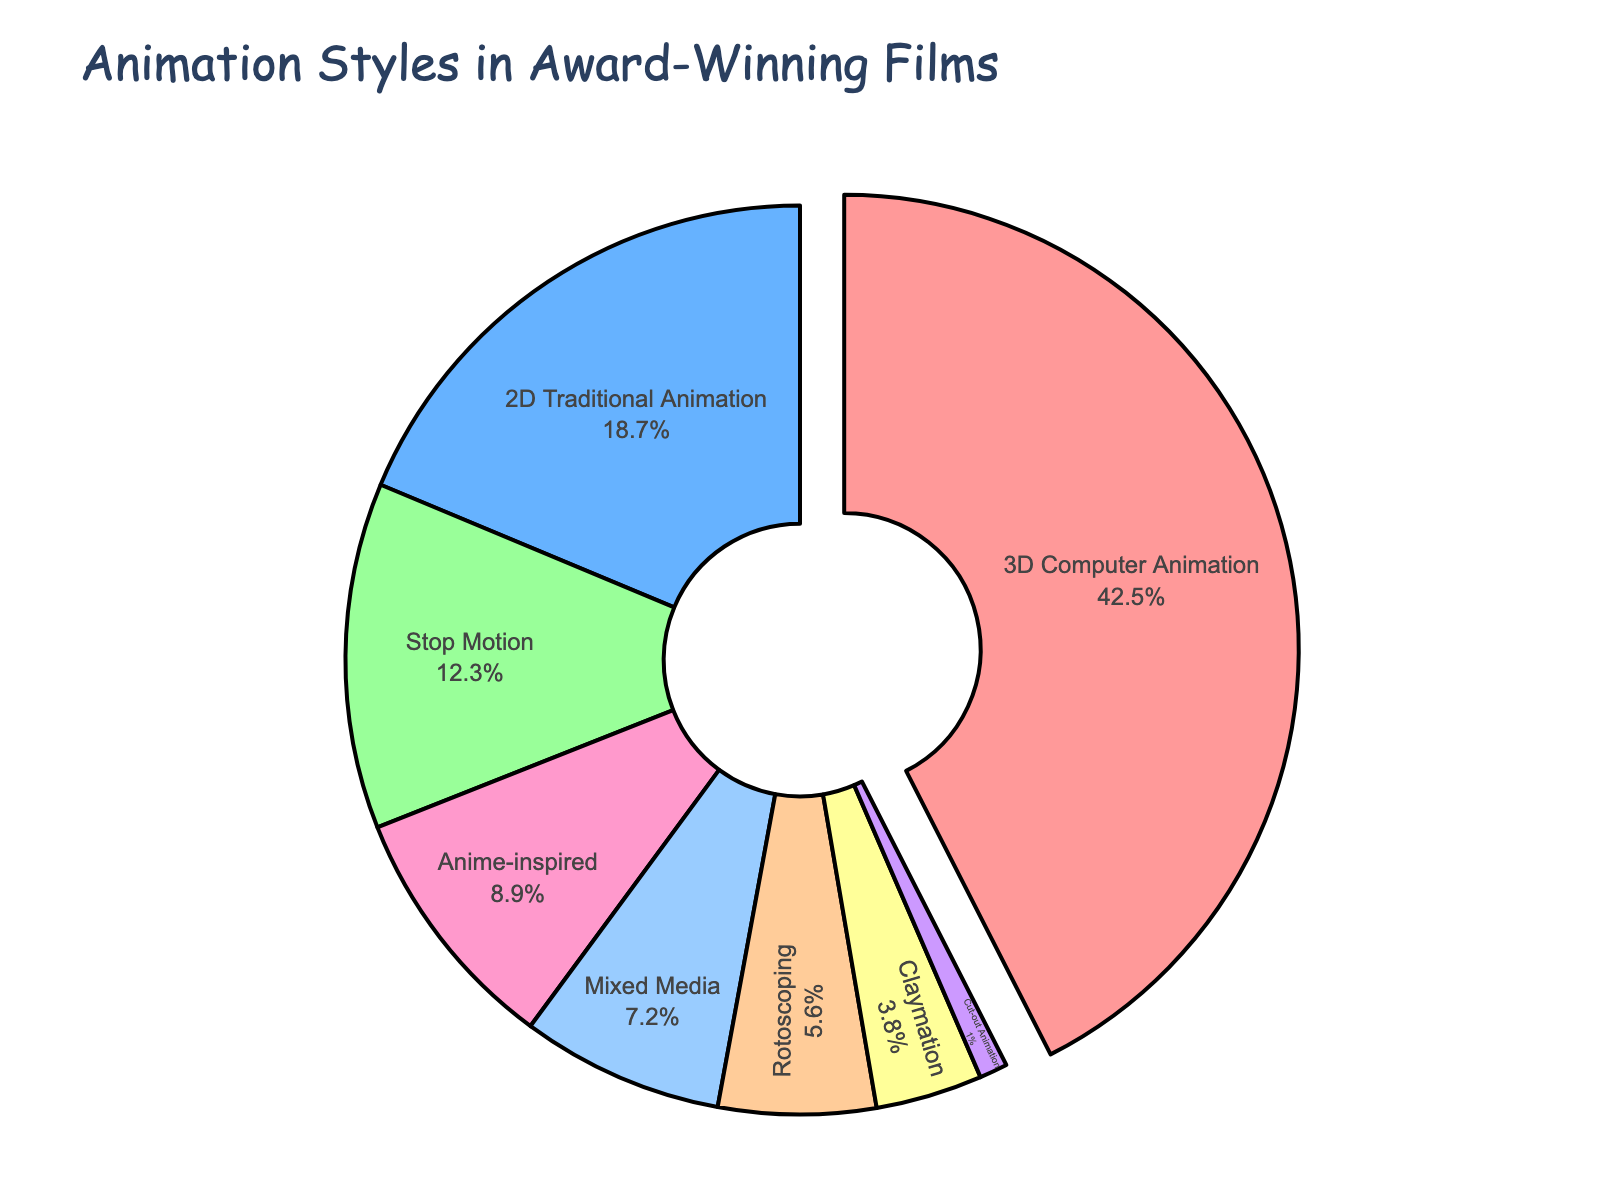What percentage of award-winning animated films used 3D Computer Animation? The segment labeled "3D Computer Animation" has a value of 42.5% as indicated on the pie chart.
Answer: 42.5% Which animation style is the least common in award-winning films? The smallest segment on the pie chart represents "Cut-out Animation", with a value of 1%.
Answer: Cut-out Animation How much larger is the percentage of 3D Computer Animation compared to 2D Traditional Animation? The value for 3D Computer Animation is 42.5%, and for 2D Traditional Animation is 18.7%. The difference is 42.5 - 18.7 = 23.8%.
Answer: 23.8% What is the combined percentage of Stop Motion and Claymation animation styles? The percentage for Stop Motion is 12.3%, and for Claymation is 3.8%. Adding them together, 12.3 + 3.8 = 16.1%.
Answer: 16.1% Which animation styles are represented by visually distinct colors on the pie chart? Each segment on the pie chart has a unique color. They are: 3D Computer Animation (red), 2D Traditional Animation (blue), Stop Motion (green), Rotoscoping (orange), Anime-inspired (pink), Mixed Media (light blue), Claymation (yellow), and Cut-out Animation (purple).
Answer: All segments are visually distinct in color Is Anime-inspired animation more common than Rotoscoping in award-winning films? Comparing the chart values, Anime-inspired animation has a percentage of 8.9%, while Rotoscoping has 5.6%. Therefore, Anime-inspired animation is more common.
Answer: Yes Which animation styles together make up more than half of the award-winning films? 3D Computer Animation (42.5%), 2D Traditional Animation (18.7%), Stop Motion (12.3%). Summing these, 42.5 + 18.7 + 12.3 = 73.5%, which is more than half.
Answer: 3D Computer Animation, 2D Traditional Animation, Stop Motion What is the visual representation style used for the most common animation style in the figure? The pie segment for 3D Computer Animation, the most common style, is slightly pulled out from the rest and has a red color.
Answer: Red, pulled out segment How much smaller is the percentage of Mixed Media compared to 3D Computer Animation? The value for Mixed Media is 7.2%, and for 3D Computer Animation is 42.5%. The difference is 42.5 - 7.2 = 35.3%.
Answer: 35.3% What is the average percentage of Anime-inspired, Mixed Media, and Claymation styles? The values are: Anime-inspired (8.9%), Mixed Media (7.2%), and Claymation (3.8%). The average is (8.9 + 7.2 + 3.8) / 3 = 19.9 / 3 ≈ 6.63%.
Answer: 6.63% 